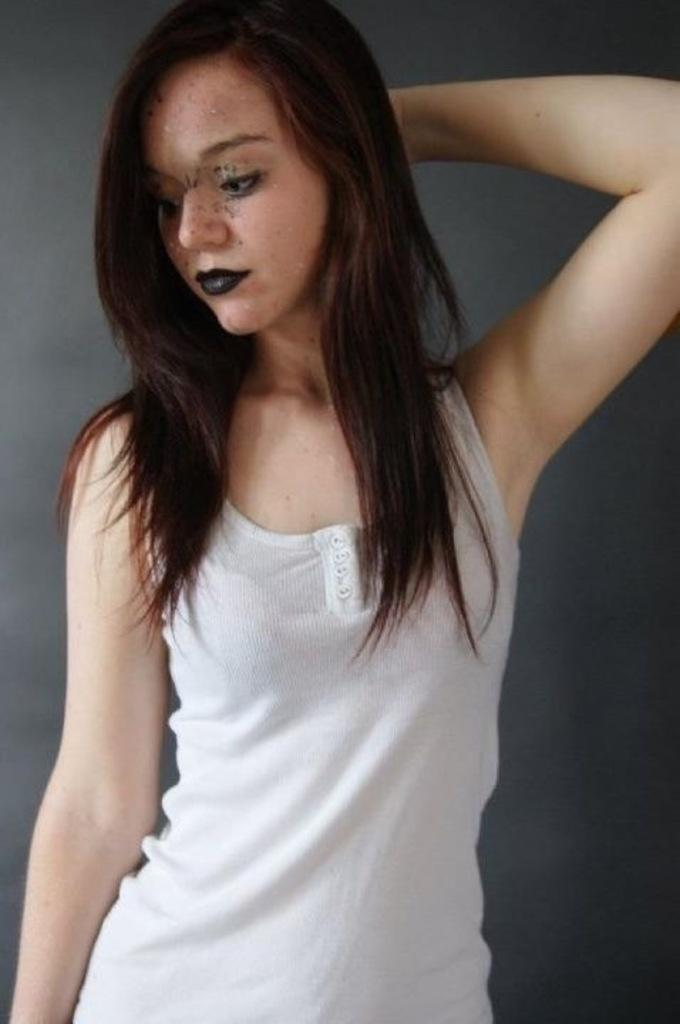What is the main subject of the image? There is a woman standing in the image. Can you describe the background of the image? The background of the image is dark. What type of cloth is the representative wearing in the image? There is no representative present in the image, and therefore no clothing can be described. 